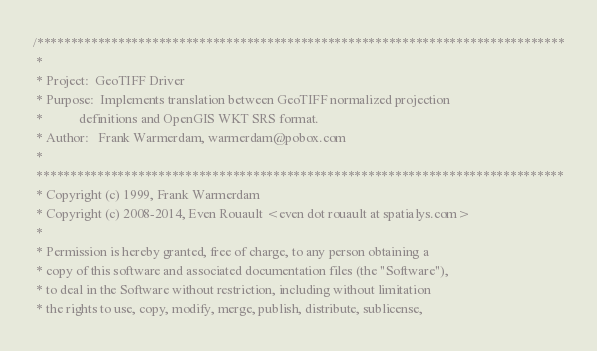<code> <loc_0><loc_0><loc_500><loc_500><_C++_>/******************************************************************************
 *
 * Project:  GeoTIFF Driver
 * Purpose:  Implements translation between GeoTIFF normalized projection
 *           definitions and OpenGIS WKT SRS format.
 * Author:   Frank Warmerdam, warmerdam@pobox.com
 *
 ******************************************************************************
 * Copyright (c) 1999, Frank Warmerdam
 * Copyright (c) 2008-2014, Even Rouault <even dot rouault at spatialys.com>
 *
 * Permission is hereby granted, free of charge, to any person obtaining a
 * copy of this software and associated documentation files (the "Software"),
 * to deal in the Software without restriction, including without limitation
 * the rights to use, copy, modify, merge, publish, distribute, sublicense,</code> 